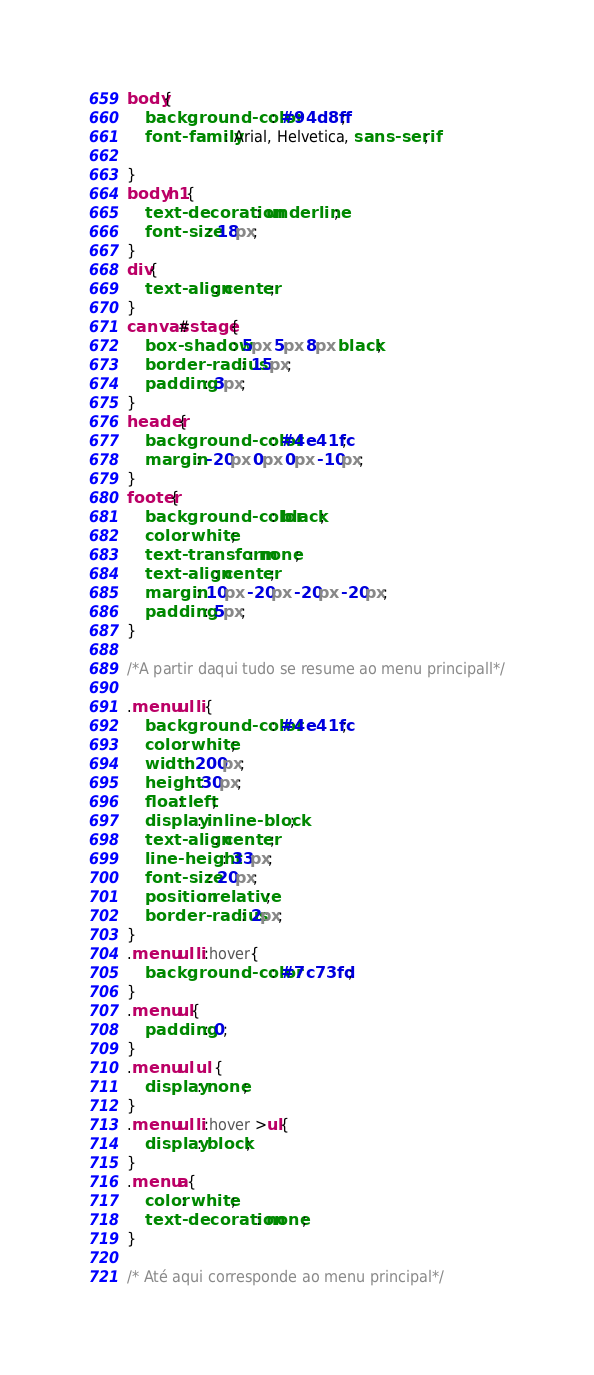<code> <loc_0><loc_0><loc_500><loc_500><_CSS_>body{
    background-color: #94d8ff;
    font-family: Arial, Helvetica, sans-serif;
    
}
body h1{
    text-decoration: underline; 
    font-size: 18px;   
}
div{
    text-align: center;
}
canvas#stage{
    box-shadow: 5px 5px 8px black;
    border-radius: 15px;
    padding: 3px;
}
header{
    background-color: #4e41fc;
    margin: -20px 0px 0px -10px;   
}
footer{
    background-color: black;
    color: white;
    text-transform: none;
    text-align: center;
    margin: 10px -20px -20px -20px;
    padding: 5px;
}

/*A partir daqui tudo se resume ao menu principall*/

.menu ul li{
    background-color: #4e41fc;
    color: white;
    width: 200px;
    height: 30px;
    float: left;
    display: inline-block;
    text-align: center;
    line-height: 33px;
    font-size: 20px;
    position: relative;
    border-radius: 2px;
}
.menu ul li:hover{
    background-color: #7c73fd ;
}
.menu ul{
    padding: 0;
}
.menu ul ul {
    display: none;
}
.menu ul li:hover >ul{
    display: block;
}
.menu a{
    color: white;
    text-decoration: none;
}

/* Até aqui corresponde ao menu principal*/



</code> 